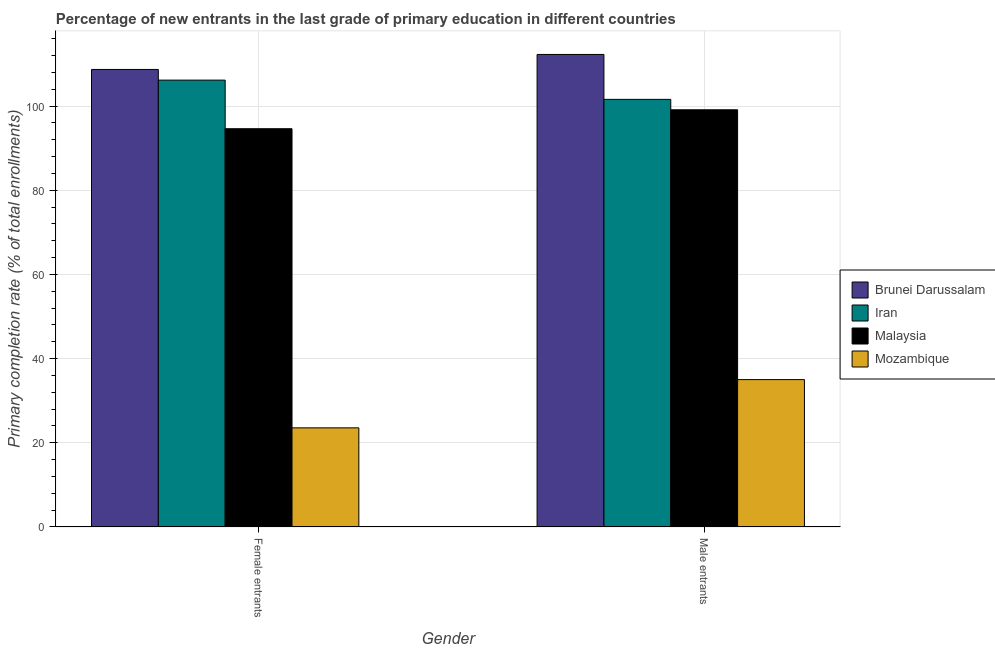How many different coloured bars are there?
Provide a short and direct response. 4. How many groups of bars are there?
Provide a succinct answer. 2. Are the number of bars per tick equal to the number of legend labels?
Give a very brief answer. Yes. How many bars are there on the 1st tick from the left?
Offer a terse response. 4. What is the label of the 1st group of bars from the left?
Give a very brief answer. Female entrants. What is the primary completion rate of female entrants in Brunei Darussalam?
Offer a very short reply. 108.7. Across all countries, what is the maximum primary completion rate of female entrants?
Offer a terse response. 108.7. Across all countries, what is the minimum primary completion rate of female entrants?
Provide a succinct answer. 23.55. In which country was the primary completion rate of male entrants maximum?
Give a very brief answer. Brunei Darussalam. In which country was the primary completion rate of female entrants minimum?
Offer a terse response. Mozambique. What is the total primary completion rate of female entrants in the graph?
Your answer should be compact. 333.03. What is the difference between the primary completion rate of male entrants in Brunei Darussalam and that in Iran?
Your answer should be very brief. 10.67. What is the difference between the primary completion rate of female entrants in Mozambique and the primary completion rate of male entrants in Malaysia?
Your answer should be compact. -75.56. What is the average primary completion rate of male entrants per country?
Make the answer very short. 86.99. What is the difference between the primary completion rate of female entrants and primary completion rate of male entrants in Mozambique?
Make the answer very short. -11.46. In how many countries, is the primary completion rate of female entrants greater than 100 %?
Your response must be concise. 2. What is the ratio of the primary completion rate of female entrants in Iran to that in Mozambique?
Your answer should be very brief. 4.51. Is the primary completion rate of male entrants in Iran less than that in Brunei Darussalam?
Provide a short and direct response. Yes. What does the 1st bar from the left in Female entrants represents?
Keep it short and to the point. Brunei Darussalam. What does the 1st bar from the right in Female entrants represents?
Ensure brevity in your answer.  Mozambique. How many bars are there?
Your response must be concise. 8. How many countries are there in the graph?
Give a very brief answer. 4. What is the difference between two consecutive major ticks on the Y-axis?
Provide a short and direct response. 20. Where does the legend appear in the graph?
Your answer should be very brief. Center right. How many legend labels are there?
Provide a succinct answer. 4. How are the legend labels stacked?
Provide a succinct answer. Vertical. What is the title of the graph?
Your answer should be compact. Percentage of new entrants in the last grade of primary education in different countries. What is the label or title of the X-axis?
Your response must be concise. Gender. What is the label or title of the Y-axis?
Your answer should be very brief. Primary completion rate (% of total enrollments). What is the Primary completion rate (% of total enrollments) in Brunei Darussalam in Female entrants?
Your response must be concise. 108.7. What is the Primary completion rate (% of total enrollments) of Iran in Female entrants?
Ensure brevity in your answer.  106.16. What is the Primary completion rate (% of total enrollments) in Malaysia in Female entrants?
Give a very brief answer. 94.62. What is the Primary completion rate (% of total enrollments) of Mozambique in Female entrants?
Give a very brief answer. 23.55. What is the Primary completion rate (% of total enrollments) in Brunei Darussalam in Male entrants?
Keep it short and to the point. 112.26. What is the Primary completion rate (% of total enrollments) of Iran in Male entrants?
Make the answer very short. 101.59. What is the Primary completion rate (% of total enrollments) in Malaysia in Male entrants?
Keep it short and to the point. 99.11. What is the Primary completion rate (% of total enrollments) of Mozambique in Male entrants?
Make the answer very short. 35.02. Across all Gender, what is the maximum Primary completion rate (% of total enrollments) in Brunei Darussalam?
Provide a succinct answer. 112.26. Across all Gender, what is the maximum Primary completion rate (% of total enrollments) of Iran?
Provide a succinct answer. 106.16. Across all Gender, what is the maximum Primary completion rate (% of total enrollments) of Malaysia?
Your answer should be very brief. 99.11. Across all Gender, what is the maximum Primary completion rate (% of total enrollments) in Mozambique?
Offer a terse response. 35.02. Across all Gender, what is the minimum Primary completion rate (% of total enrollments) in Brunei Darussalam?
Make the answer very short. 108.7. Across all Gender, what is the minimum Primary completion rate (% of total enrollments) of Iran?
Make the answer very short. 101.59. Across all Gender, what is the minimum Primary completion rate (% of total enrollments) of Malaysia?
Your answer should be compact. 94.62. Across all Gender, what is the minimum Primary completion rate (% of total enrollments) in Mozambique?
Provide a succinct answer. 23.55. What is the total Primary completion rate (% of total enrollments) in Brunei Darussalam in the graph?
Your response must be concise. 220.96. What is the total Primary completion rate (% of total enrollments) of Iran in the graph?
Keep it short and to the point. 207.75. What is the total Primary completion rate (% of total enrollments) of Malaysia in the graph?
Your response must be concise. 193.73. What is the total Primary completion rate (% of total enrollments) of Mozambique in the graph?
Your response must be concise. 58.57. What is the difference between the Primary completion rate (% of total enrollments) of Brunei Darussalam in Female entrants and that in Male entrants?
Keep it short and to the point. -3.56. What is the difference between the Primary completion rate (% of total enrollments) of Iran in Female entrants and that in Male entrants?
Your answer should be very brief. 4.58. What is the difference between the Primary completion rate (% of total enrollments) of Malaysia in Female entrants and that in Male entrants?
Offer a terse response. -4.5. What is the difference between the Primary completion rate (% of total enrollments) of Mozambique in Female entrants and that in Male entrants?
Give a very brief answer. -11.46. What is the difference between the Primary completion rate (% of total enrollments) of Brunei Darussalam in Female entrants and the Primary completion rate (% of total enrollments) of Iran in Male entrants?
Your answer should be very brief. 7.11. What is the difference between the Primary completion rate (% of total enrollments) in Brunei Darussalam in Female entrants and the Primary completion rate (% of total enrollments) in Malaysia in Male entrants?
Ensure brevity in your answer.  9.59. What is the difference between the Primary completion rate (% of total enrollments) of Brunei Darussalam in Female entrants and the Primary completion rate (% of total enrollments) of Mozambique in Male entrants?
Offer a terse response. 73.68. What is the difference between the Primary completion rate (% of total enrollments) in Iran in Female entrants and the Primary completion rate (% of total enrollments) in Malaysia in Male entrants?
Keep it short and to the point. 7.05. What is the difference between the Primary completion rate (% of total enrollments) of Iran in Female entrants and the Primary completion rate (% of total enrollments) of Mozambique in Male entrants?
Your answer should be compact. 71.15. What is the difference between the Primary completion rate (% of total enrollments) of Malaysia in Female entrants and the Primary completion rate (% of total enrollments) of Mozambique in Male entrants?
Give a very brief answer. 59.6. What is the average Primary completion rate (% of total enrollments) of Brunei Darussalam per Gender?
Offer a terse response. 110.48. What is the average Primary completion rate (% of total enrollments) of Iran per Gender?
Give a very brief answer. 103.88. What is the average Primary completion rate (% of total enrollments) of Malaysia per Gender?
Make the answer very short. 96.86. What is the average Primary completion rate (% of total enrollments) of Mozambique per Gender?
Ensure brevity in your answer.  29.28. What is the difference between the Primary completion rate (% of total enrollments) in Brunei Darussalam and Primary completion rate (% of total enrollments) in Iran in Female entrants?
Ensure brevity in your answer.  2.54. What is the difference between the Primary completion rate (% of total enrollments) in Brunei Darussalam and Primary completion rate (% of total enrollments) in Malaysia in Female entrants?
Provide a succinct answer. 14.08. What is the difference between the Primary completion rate (% of total enrollments) of Brunei Darussalam and Primary completion rate (% of total enrollments) of Mozambique in Female entrants?
Provide a succinct answer. 85.15. What is the difference between the Primary completion rate (% of total enrollments) in Iran and Primary completion rate (% of total enrollments) in Malaysia in Female entrants?
Make the answer very short. 11.55. What is the difference between the Primary completion rate (% of total enrollments) in Iran and Primary completion rate (% of total enrollments) in Mozambique in Female entrants?
Your answer should be compact. 82.61. What is the difference between the Primary completion rate (% of total enrollments) of Malaysia and Primary completion rate (% of total enrollments) of Mozambique in Female entrants?
Keep it short and to the point. 71.06. What is the difference between the Primary completion rate (% of total enrollments) of Brunei Darussalam and Primary completion rate (% of total enrollments) of Iran in Male entrants?
Ensure brevity in your answer.  10.67. What is the difference between the Primary completion rate (% of total enrollments) in Brunei Darussalam and Primary completion rate (% of total enrollments) in Malaysia in Male entrants?
Offer a very short reply. 13.15. What is the difference between the Primary completion rate (% of total enrollments) in Brunei Darussalam and Primary completion rate (% of total enrollments) in Mozambique in Male entrants?
Your response must be concise. 77.24. What is the difference between the Primary completion rate (% of total enrollments) of Iran and Primary completion rate (% of total enrollments) of Malaysia in Male entrants?
Offer a terse response. 2.47. What is the difference between the Primary completion rate (% of total enrollments) in Iran and Primary completion rate (% of total enrollments) in Mozambique in Male entrants?
Your response must be concise. 66.57. What is the difference between the Primary completion rate (% of total enrollments) of Malaysia and Primary completion rate (% of total enrollments) of Mozambique in Male entrants?
Keep it short and to the point. 64.1. What is the ratio of the Primary completion rate (% of total enrollments) in Brunei Darussalam in Female entrants to that in Male entrants?
Offer a very short reply. 0.97. What is the ratio of the Primary completion rate (% of total enrollments) in Iran in Female entrants to that in Male entrants?
Make the answer very short. 1.04. What is the ratio of the Primary completion rate (% of total enrollments) of Malaysia in Female entrants to that in Male entrants?
Your response must be concise. 0.95. What is the ratio of the Primary completion rate (% of total enrollments) of Mozambique in Female entrants to that in Male entrants?
Offer a very short reply. 0.67. What is the difference between the highest and the second highest Primary completion rate (% of total enrollments) in Brunei Darussalam?
Give a very brief answer. 3.56. What is the difference between the highest and the second highest Primary completion rate (% of total enrollments) of Iran?
Ensure brevity in your answer.  4.58. What is the difference between the highest and the second highest Primary completion rate (% of total enrollments) of Malaysia?
Provide a succinct answer. 4.5. What is the difference between the highest and the second highest Primary completion rate (% of total enrollments) of Mozambique?
Ensure brevity in your answer.  11.46. What is the difference between the highest and the lowest Primary completion rate (% of total enrollments) in Brunei Darussalam?
Offer a terse response. 3.56. What is the difference between the highest and the lowest Primary completion rate (% of total enrollments) in Iran?
Give a very brief answer. 4.58. What is the difference between the highest and the lowest Primary completion rate (% of total enrollments) in Malaysia?
Your response must be concise. 4.5. What is the difference between the highest and the lowest Primary completion rate (% of total enrollments) of Mozambique?
Offer a very short reply. 11.46. 